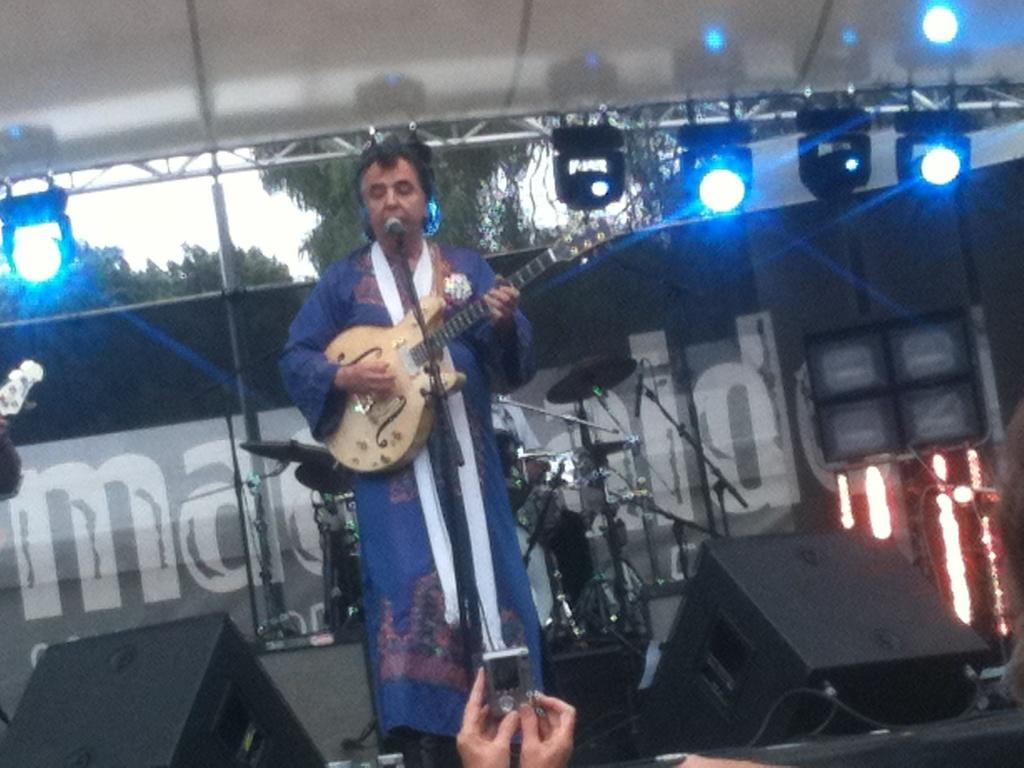What is the man on the stage doing? The man is singing on a microphone and playing a guitar. What other objects are present on the stage? There are musical instruments behind the man. What can be seen in the background of the image? Trees and the sky are visible in the background. What is the person in front of the man doing? The person is capturing photos. Can you see any bees buzzing around the man while he is singing? No, there are no bees visible in the image. What finger is the man using to play the guitar? The image does not show which finger the man is using to play the guitar. 